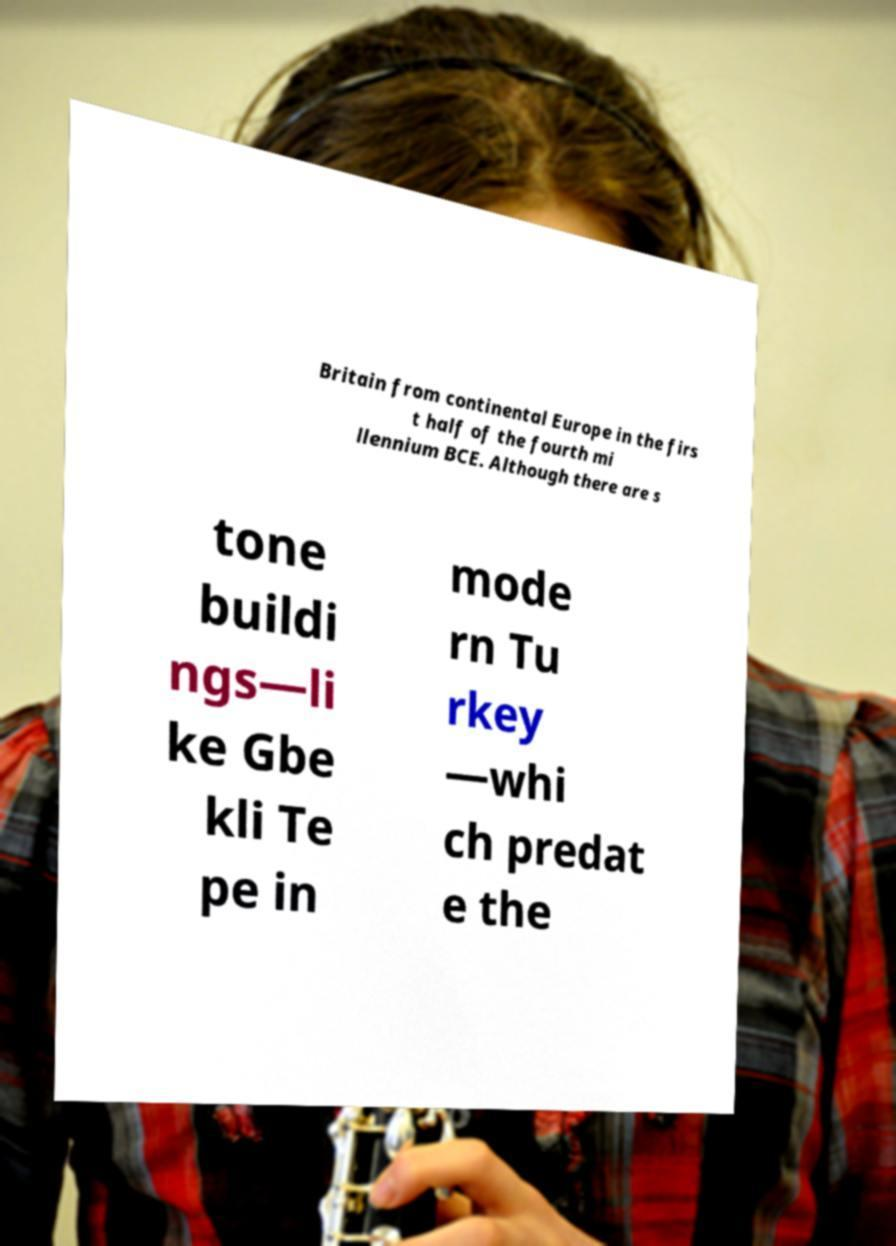Can you accurately transcribe the text from the provided image for me? Britain from continental Europe in the firs t half of the fourth mi llennium BCE. Although there are s tone buildi ngs—li ke Gbe kli Te pe in mode rn Tu rkey —whi ch predat e the 